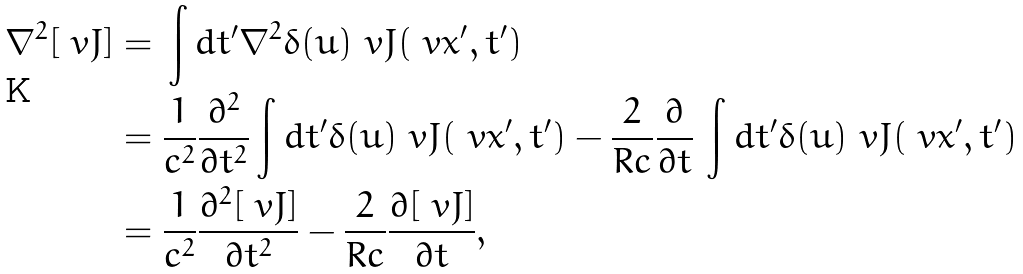<formula> <loc_0><loc_0><loc_500><loc_500>\nabla ^ { 2 } [ \ v J ] & = \, \int d t ^ { \prime } \nabla ^ { 2 } \delta ( u ) \ v J ( \ v x ^ { \prime } , t ^ { \prime } ) \\ & = \frac { 1 } { c ^ { 2 } } \frac { \partial ^ { 2 } } { \partial t ^ { 2 } } \int d t ^ { \prime } \delta ( u ) \ v J ( \ v x ^ { \prime } , t ^ { \prime } ) - \frac { 2 } { R c } \frac { \partial } { \partial t } \, \int d t ^ { \prime } \delta ( u ) \ v J ( \ v x ^ { \prime } , t ^ { \prime } ) \\ & = \frac { 1 } { c ^ { 2 } } \frac { \partial ^ { 2 } [ \ v J ] } { \partial t ^ { 2 } } - \frac { 2 } { R c } \frac { \partial [ \ v J ] } { \partial t } ,</formula> 